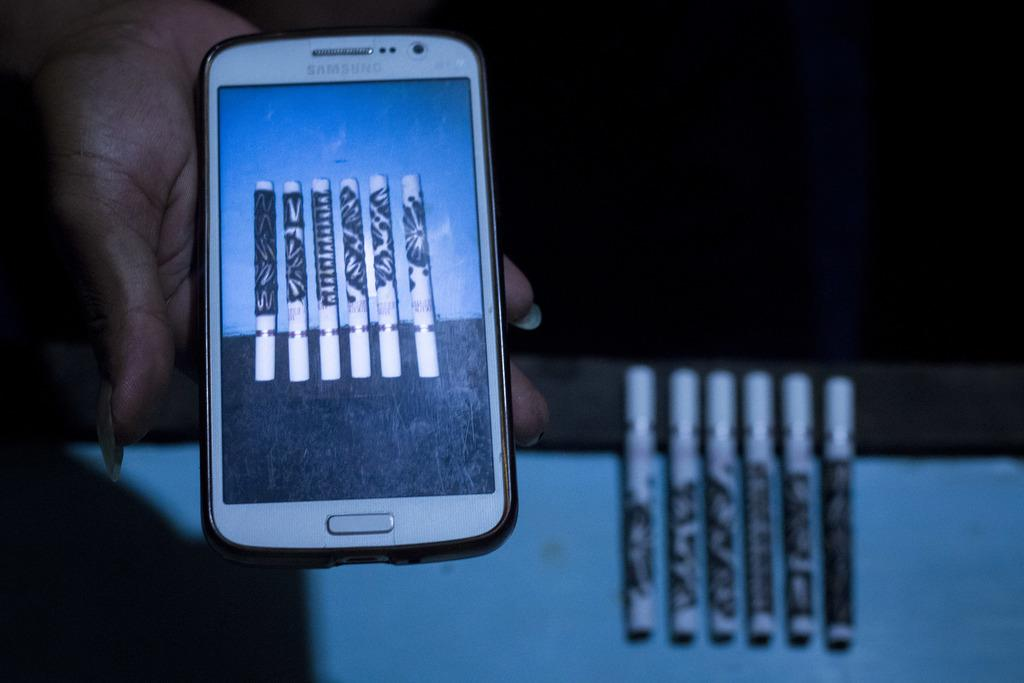<image>
Provide a brief description of the given image. The white cell phone is from the company Samsung 